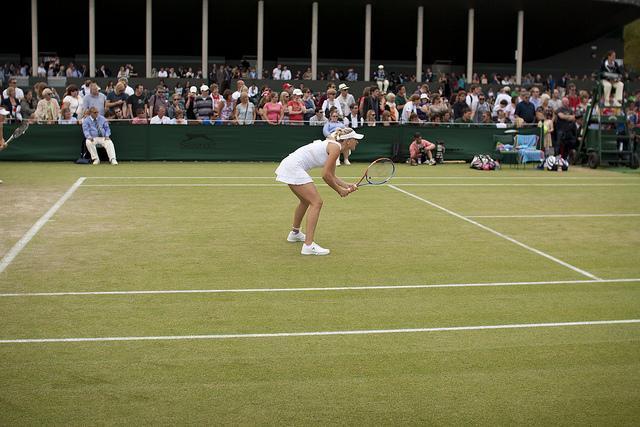How many people are there?
Give a very brief answer. 2. 